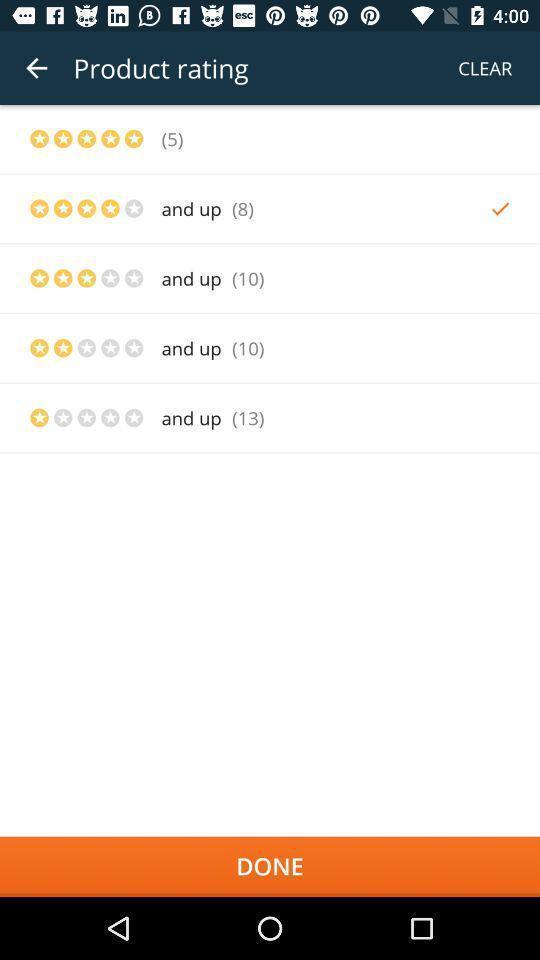Describe the content in this image. Screen displaying list of filter options in a shopping application. 